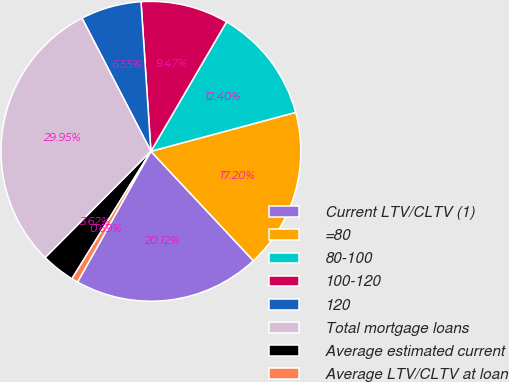<chart> <loc_0><loc_0><loc_500><loc_500><pie_chart><fcel>Current LTV/CLTV (1)<fcel>=80<fcel>80-100<fcel>100-120<fcel>120<fcel>Total mortgage loans<fcel>Average estimated current<fcel>Average LTV/CLTV at loan<nl><fcel>20.12%<fcel>17.2%<fcel>12.4%<fcel>9.47%<fcel>6.55%<fcel>29.95%<fcel>3.62%<fcel>0.69%<nl></chart> 